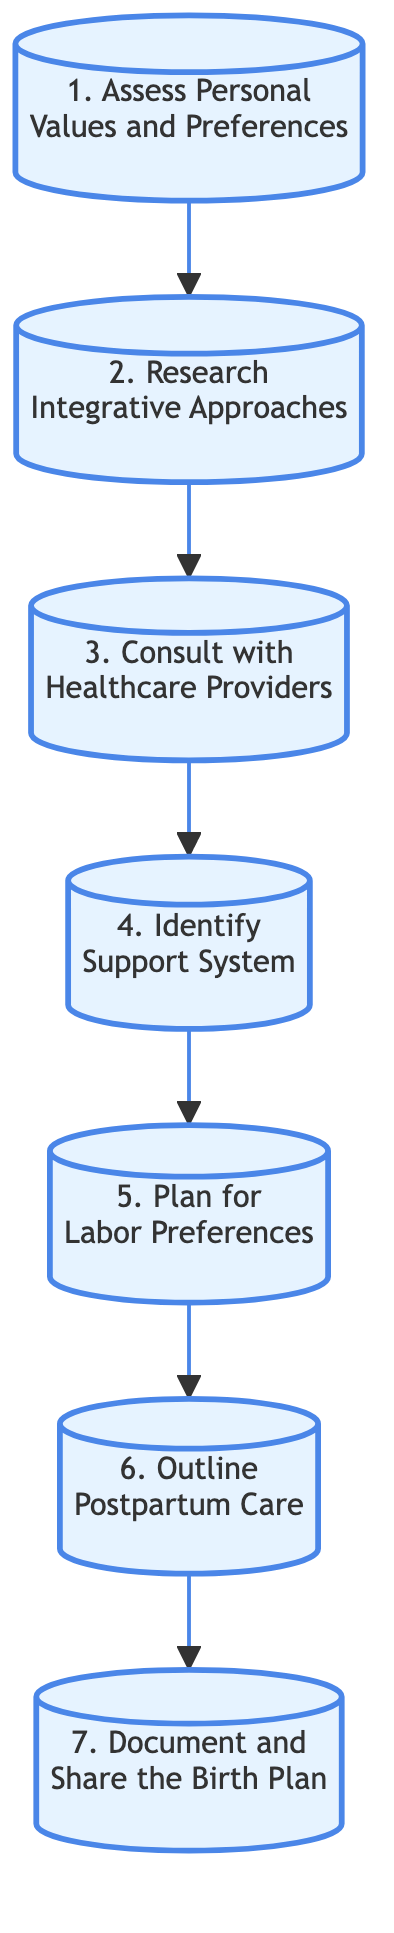What is the first step in creating a birth plan? The first step is represented by the node labeled "1", which states "Assess Personal Values and Preferences." This is the starting point of the directed graph, indicating it is foundational to the birth planning process.
Answer: Assess Personal Values and Preferences How many total steps are outlined in the diagram? To determine the total number of steps, I counted the individual nodes in the directed graph, which are numbered from 1 to 7. Therefore, there are seven distinct steps.
Answer: 7 What is the last step in the sequence? The last step is represented by the node labeled "7", which is "Document and Share the Birth Plan." This indicates it is the final action to be taken after all previous steps have been completed.
Answer: Document and Share the Birth Plan Which step follows "Consult with Healthcare Providers"? By examining the directed connections in the graph, "Consult with Healthcare Providers" is labeled as step 3, and the next step it leads to is labeled step 4, which is "Identify Support System." Thus, it is a direct follow-up.
Answer: Identify Support System What type of approaches are considered in step 2? Step 2 engages with "Integrative Approaches," specifically focusing on natural birth techniques. This indicates that the knowledge gathered includes various complementary practices that support a natural childbirth experience.
Answer: Integrative Approaches What is the main focus of step 6? The main focus of step 6, labeled "Outline Postpartum Care," is to establish preferences for care after childbirth, which includes options such as breastfeeding and emotional support. It is clearly outlined in the description of this step.
Answer: Outline Postpartum Care How does step 5 relate to previous steps? Step 5, which focuses on planning for labor preferences, is directly connected to step 4. This means that after identifying the support system, the next logical step is to choose preferred methods and environment for labor, emphasizing a smooth transition within the overall process.
Answer: Plan for Labor Preferences 